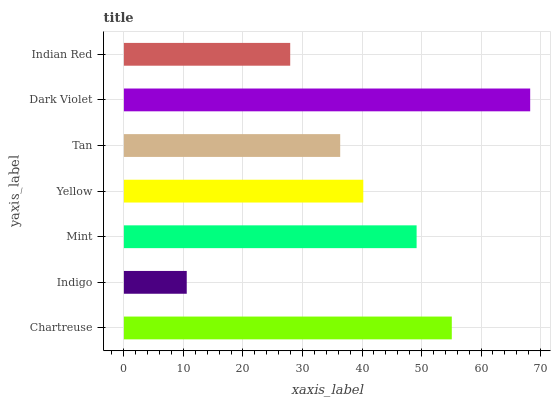Is Indigo the minimum?
Answer yes or no. Yes. Is Dark Violet the maximum?
Answer yes or no. Yes. Is Mint the minimum?
Answer yes or no. No. Is Mint the maximum?
Answer yes or no. No. Is Mint greater than Indigo?
Answer yes or no. Yes. Is Indigo less than Mint?
Answer yes or no. Yes. Is Indigo greater than Mint?
Answer yes or no. No. Is Mint less than Indigo?
Answer yes or no. No. Is Yellow the high median?
Answer yes or no. Yes. Is Yellow the low median?
Answer yes or no. Yes. Is Chartreuse the high median?
Answer yes or no. No. Is Mint the low median?
Answer yes or no. No. 